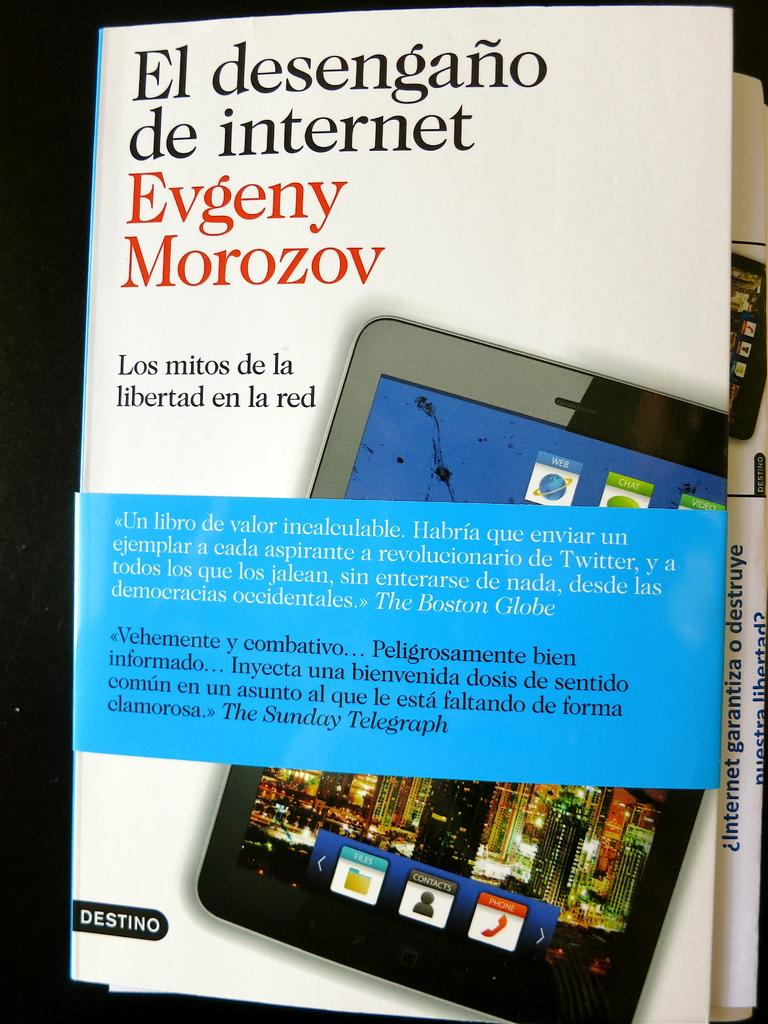What can be seen on the two posts in the image? There are text and images on the two posts in the image. What is the color of the background in the image? The background of the image is dark. What type of work is being performed on the stage in the image? There is no stage or work being performed in the image; it only features two posts with text and images against a dark background. How many clocks are visible on the posts in the image? There is no mention of clocks in the image; it only features text and images on the two posts. 